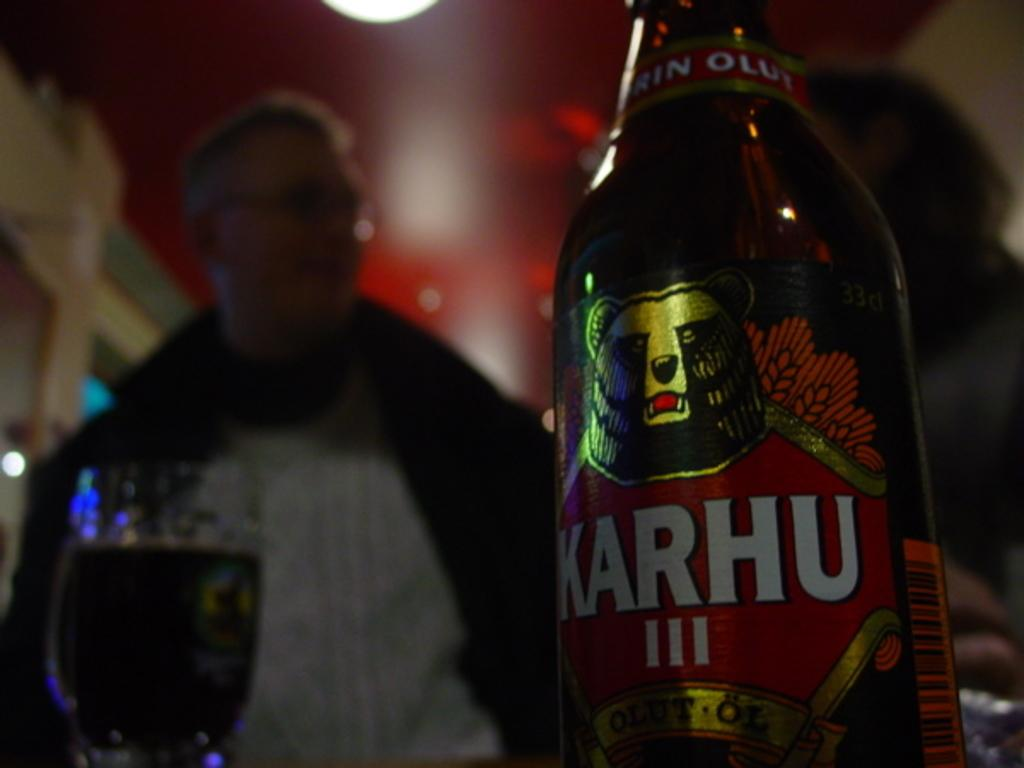<image>
Summarize the visual content of the image. a bottle of karhu III next to a glass and person 